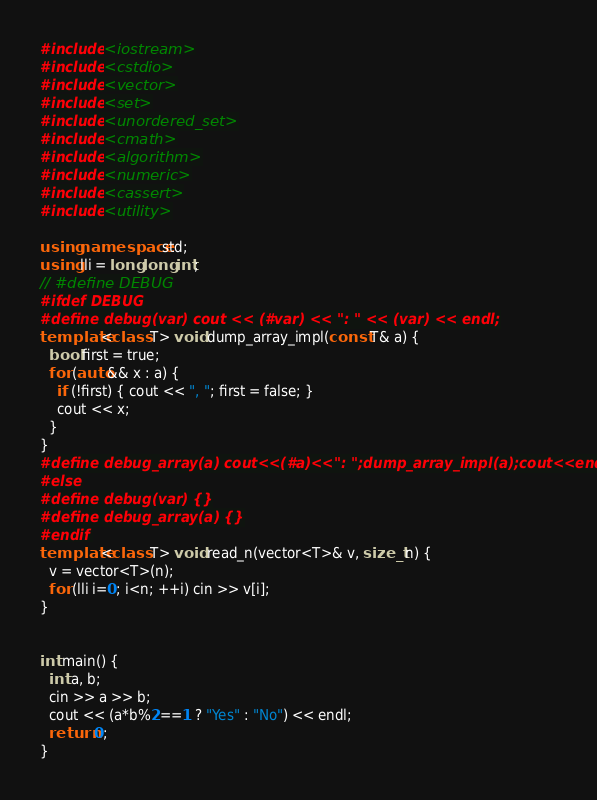<code> <loc_0><loc_0><loc_500><loc_500><_C++_>#include <iostream>
#include <cstdio>
#include <vector>
#include <set>
#include <unordered_set>
#include <cmath>
#include <algorithm>
#include <numeric>
#include <cassert>
#include <utility>

using namespace std;
using lli = long long int;
// #define DEBUG
#ifdef DEBUG
#define debug(var) cout << (#var) << ": " << (var) << endl;
template<class T> void dump_array_impl(const T& a) {
  bool first = true;
  for (auto&& x : a) {
    if (!first) { cout << ", "; first = false; }
    cout << x;
  }
}
#define debug_array(a) cout<<(#a)<<": ";dump_array_impl(a);cout<<endl
#else
#define debug(var) {}
#define debug_array(a) {}
#endif
template<class T> void read_n(vector<T>& v, size_t n) {
  v = vector<T>(n);
  for (lli i=0; i<n; ++i) cin >> v[i];
}


int main() {
  int a, b;
  cin >> a >> b;
  cout << (a*b%2==1 ? "Yes" : "No") << endl;
  return 0;
}
</code> 